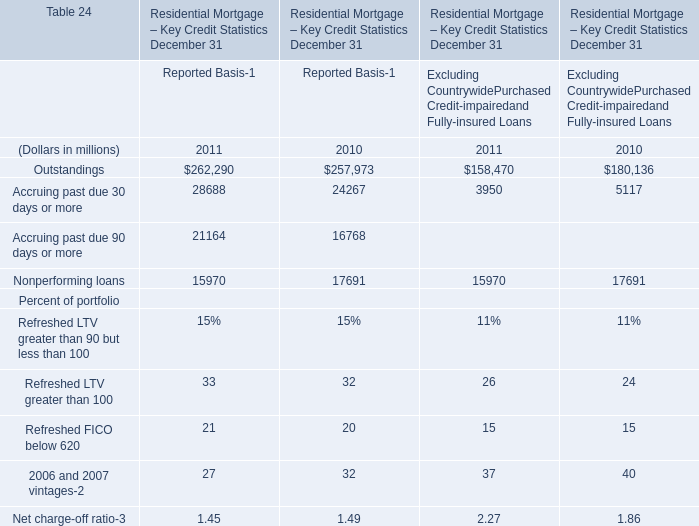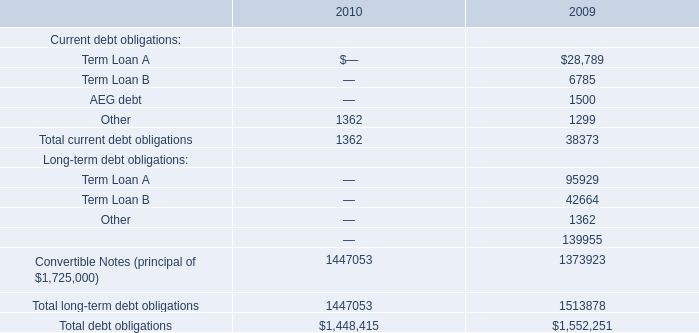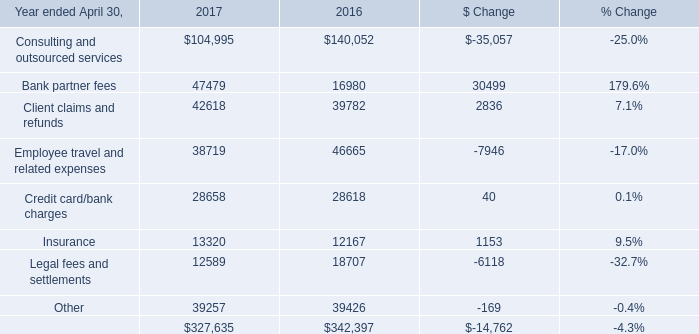In the year with lowest amount of Outstandings, what's the increasing rate of Accruing past due 30 days or more for Reported Basis? 
Computations: ((28688 - 24267) / 28688)
Answer: 0.15411. 